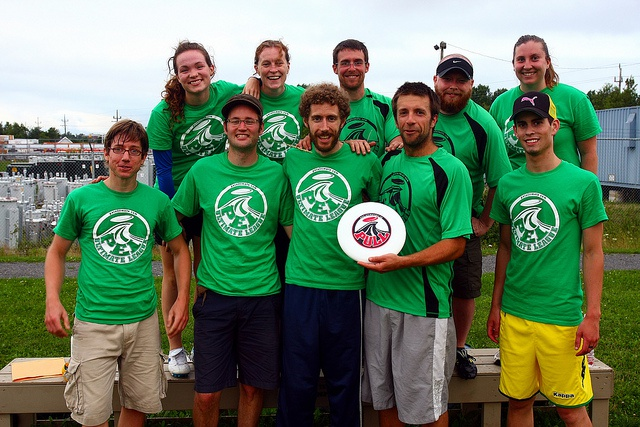Describe the objects in this image and their specific colors. I can see people in white, darkgreen, green, olive, and black tones, people in white, green, darkgreen, and gray tones, people in white, gray, black, darkgreen, and green tones, people in white, black, green, darkgreen, and maroon tones, and people in white, black, green, and darkgreen tones in this image. 